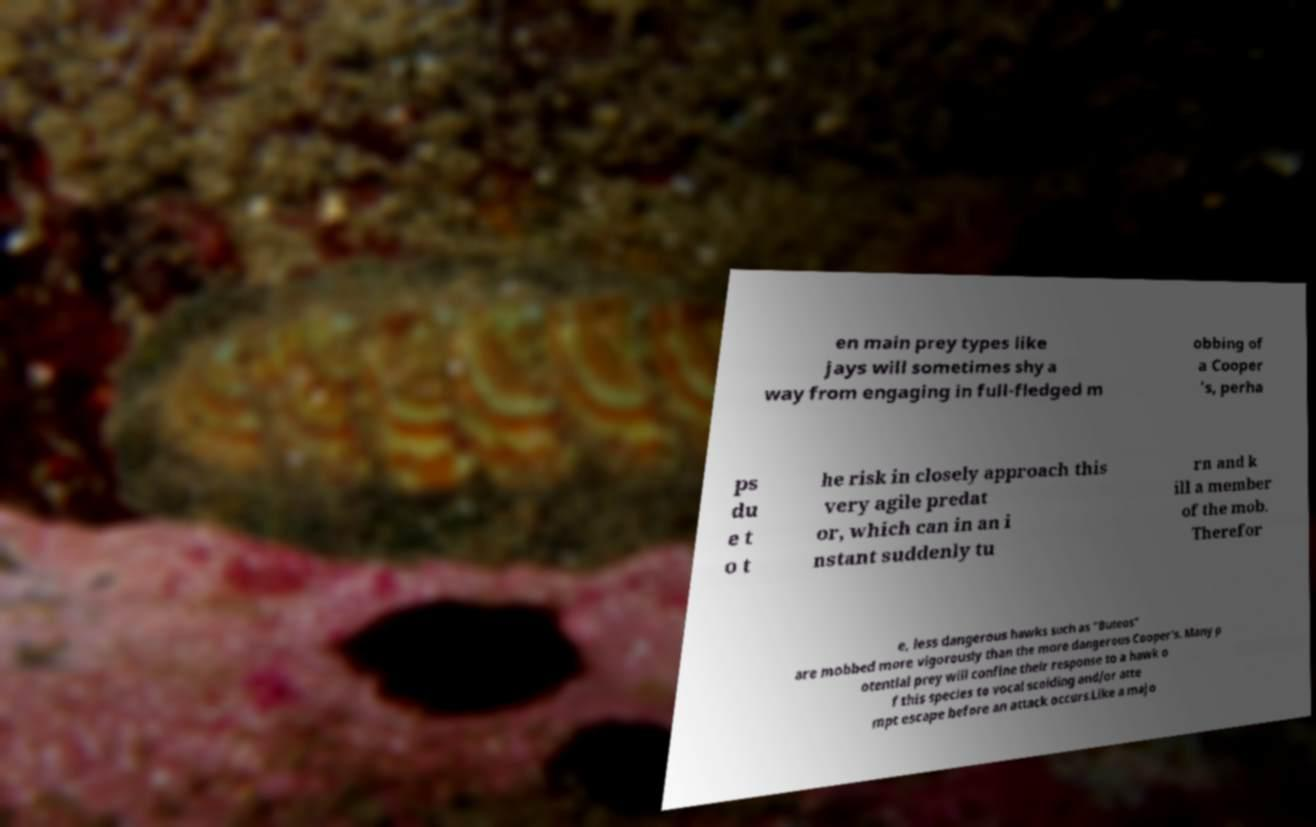Can you accurately transcribe the text from the provided image for me? en main prey types like jays will sometimes shy a way from engaging in full-fledged m obbing of a Cooper 's, perha ps du e t o t he risk in closely approach this very agile predat or, which can in an i nstant suddenly tu rn and k ill a member of the mob. Therefor e, less dangerous hawks such as "Buteos" are mobbed more vigorously than the more dangerous Cooper's. Many p otential prey will confine their response to a hawk o f this species to vocal scolding and/or atte mpt escape before an attack occurs.Like a majo 